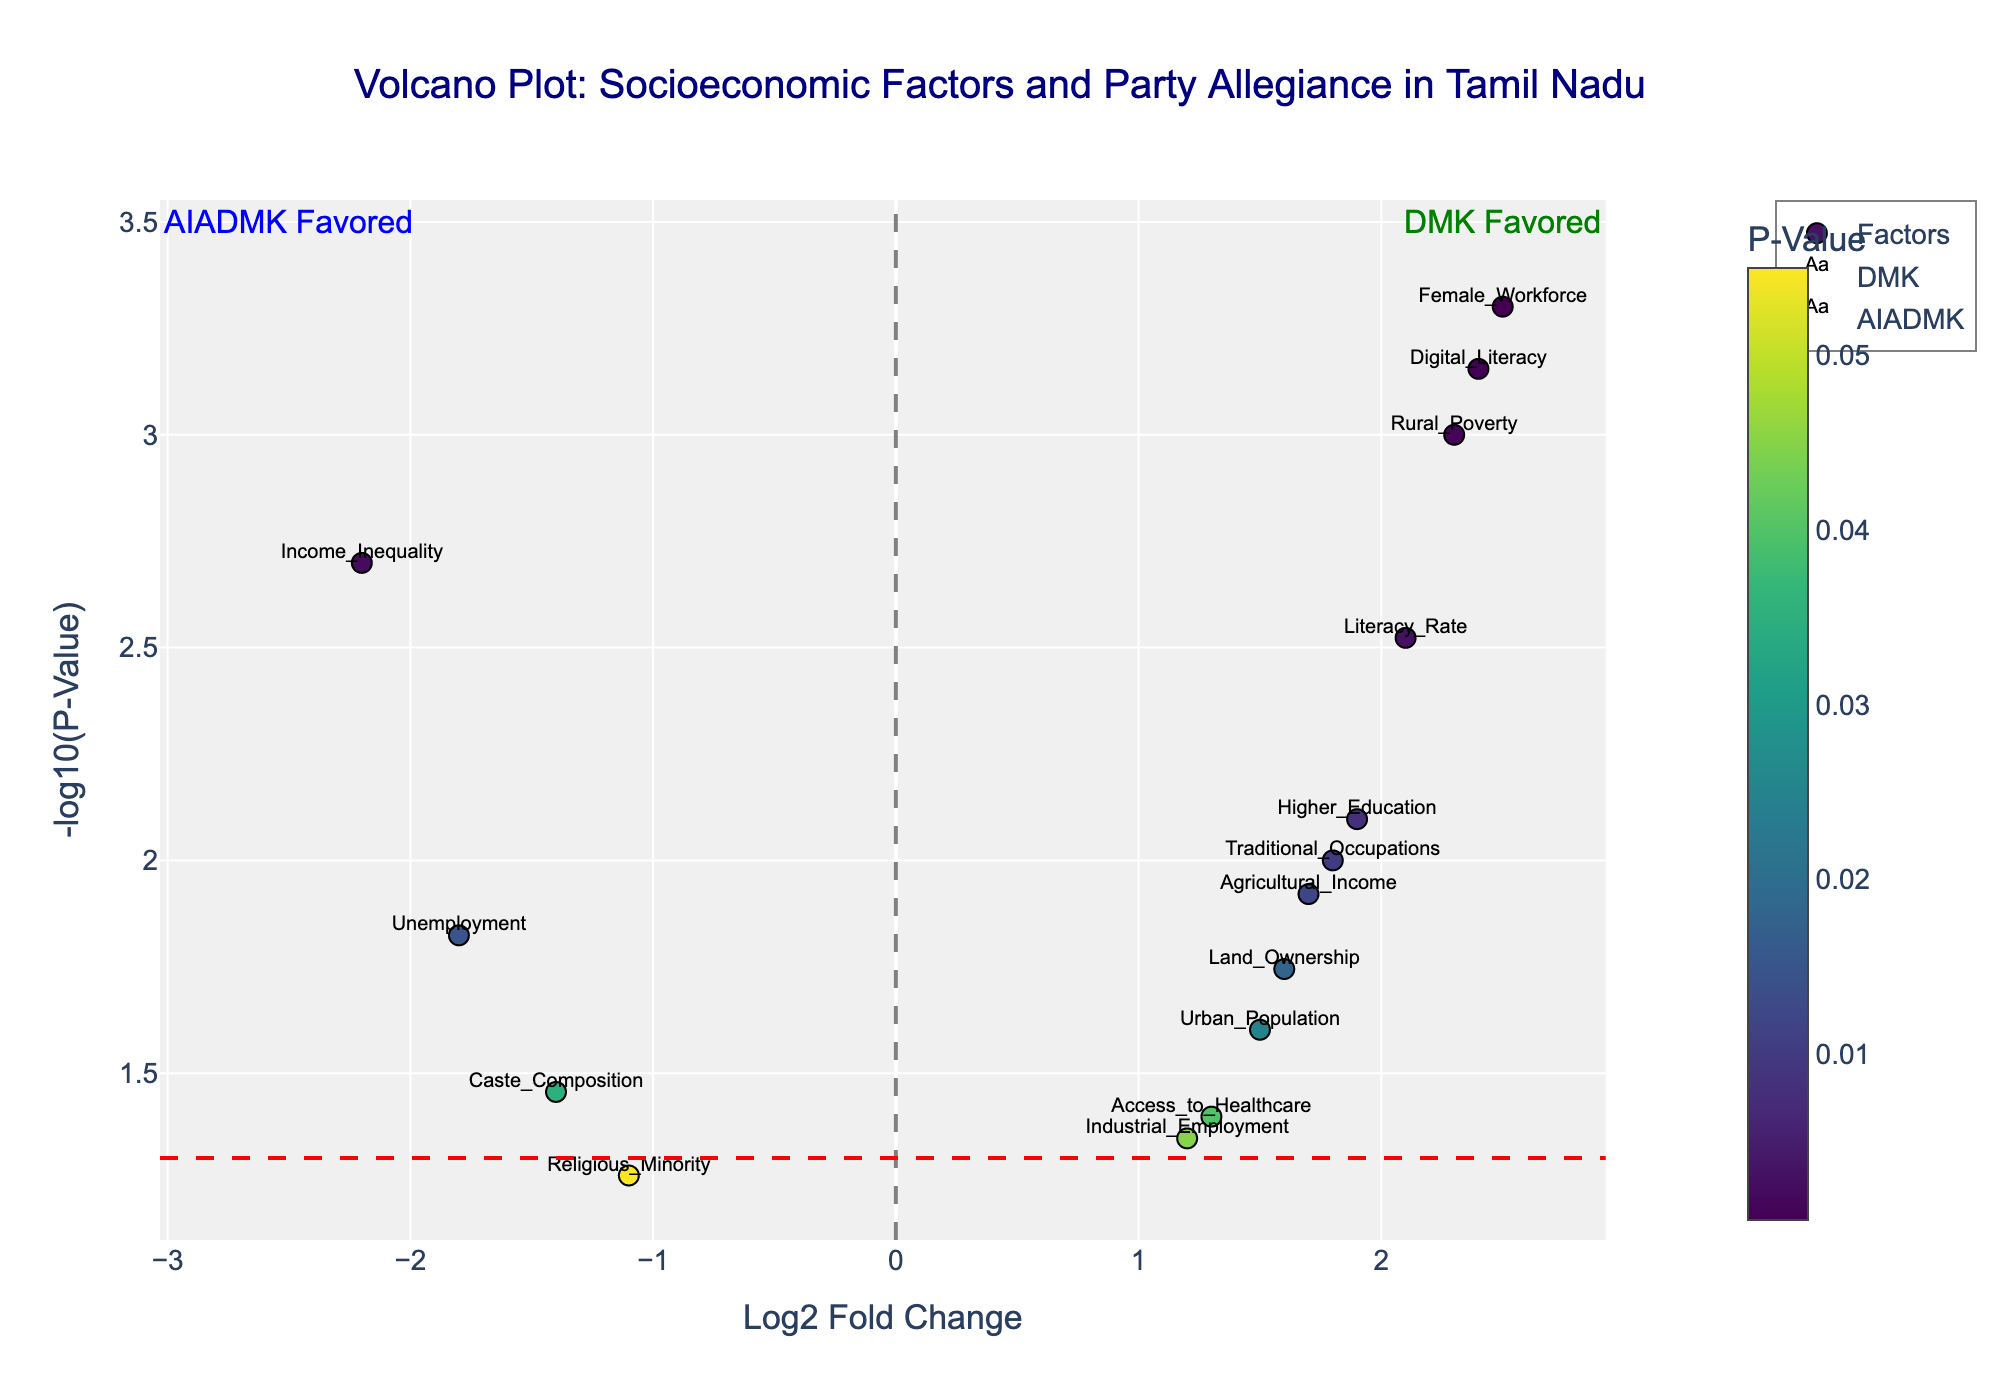How many socioeconomic factors are represented in the figure? The figure contains markers, each representing a socioeconomic factor. By counting the unique factors labeled in the plot, we can determine the total number.
Answer: 14 What does the vertical dashed line represent? The figure includes a vertical dashed line at x=0. This represents the threshold for the log2 fold change, separating factors that favor DMK (positive values) from those that favor AIADMK (negative values).
Answer: Threshold between DMK and AIADMK favoring factors Which socioeconomic factor has the highest significance in favor of DMK? In the plot, the y-axis represents -log10(p-value), where a higher value indicates greater significance. The factor with the highest y-axis value for DMK is the most significant.
Answer: Female Workforce What is the log2 fold change for the factor "Rural Poverty" and which party does it favor? By locating the label "Rural Poverty" in the plot, we can read its x-value and determine the corresponding log2 fold change. The color and position indicate the associated party.
Answer: 2.3, AIADMK Compare the significance of Higher Education and Agricultural Income. Which one has a lower p-value? The y-axis (-log10(p-value)) indicates significance, where a higher value represents a lower p-value. By comparing the y-values of Higher Education and Agricultural Income, we determine which is more significant.
Answer: Higher Education How many factors favor AIADMK? By counting the number of data points (markers) with negative log2 fold change values (x-axis < 0), we determine the number of factors that favor AIADMK.
Answer: 7 Which socioeconomic factors favor DMK but have a p-value greater than 0.05? Factors favoring DMK will have positive log2 fold change. To find those with p-values greater than 0.05, identify points below the red horizontal line at -log10(0.05).
Answer: Industrial Employment, Access to Healthcare What does the red horizontal line represent? The red horizontal line is at y=-log10(0.05). This represents the significance threshold, where points above this line have p-values less than 0.05 (statistically significant), and points below have p-values greater than 0.05.
Answer: Significance threshold (p = 0.05) Which party is associated with higher Digital Literacy, and what is the log2 fold change? Locate the label "Digital Literacy" in the plot to find its x-value, which indicates the log2 fold change, and associate it with the party based on its position and color.
Answer: DMK, 2.4 Identify and compare the significance of factors related to Income (Income Inequality and Agricultural Income). Which is more significant and for which party? By comparing the y-values (-log10(p-value)) of Income Inequality and Agricultural Income, the higher value indicates greater significance. The party allegiance is identified by the x-value (positive for DMK, negative for AIADMK).
Answer: Income Inequality for DMK 